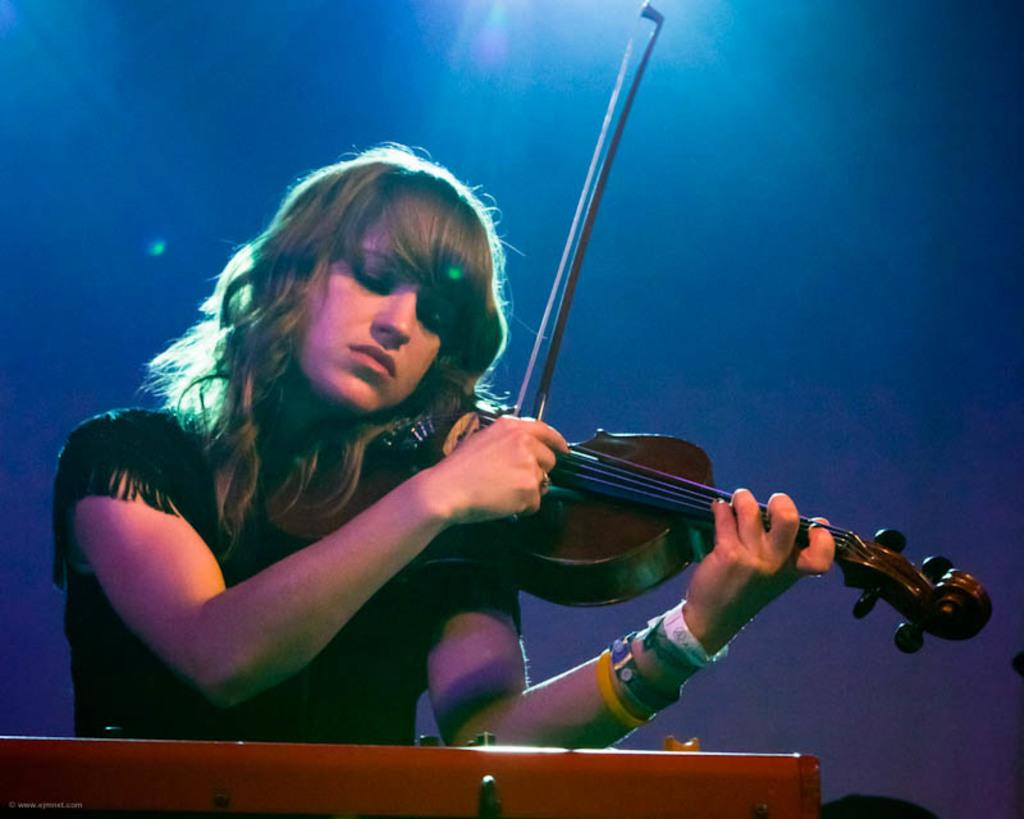Who is the main subject in the image? There is a woman in the image. What is the woman doing in the image? The woman is playing a guitar. What type of celery is the woman using as a guitar pick in the image? There is no celery present in the image, and the woman is not using any celery as a guitar pick. 